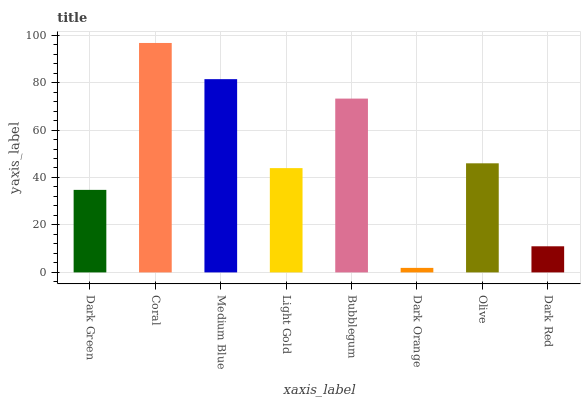Is Dark Orange the minimum?
Answer yes or no. Yes. Is Coral the maximum?
Answer yes or no. Yes. Is Medium Blue the minimum?
Answer yes or no. No. Is Medium Blue the maximum?
Answer yes or no. No. Is Coral greater than Medium Blue?
Answer yes or no. Yes. Is Medium Blue less than Coral?
Answer yes or no. Yes. Is Medium Blue greater than Coral?
Answer yes or no. No. Is Coral less than Medium Blue?
Answer yes or no. No. Is Olive the high median?
Answer yes or no. Yes. Is Light Gold the low median?
Answer yes or no. Yes. Is Dark Red the high median?
Answer yes or no. No. Is Olive the low median?
Answer yes or no. No. 